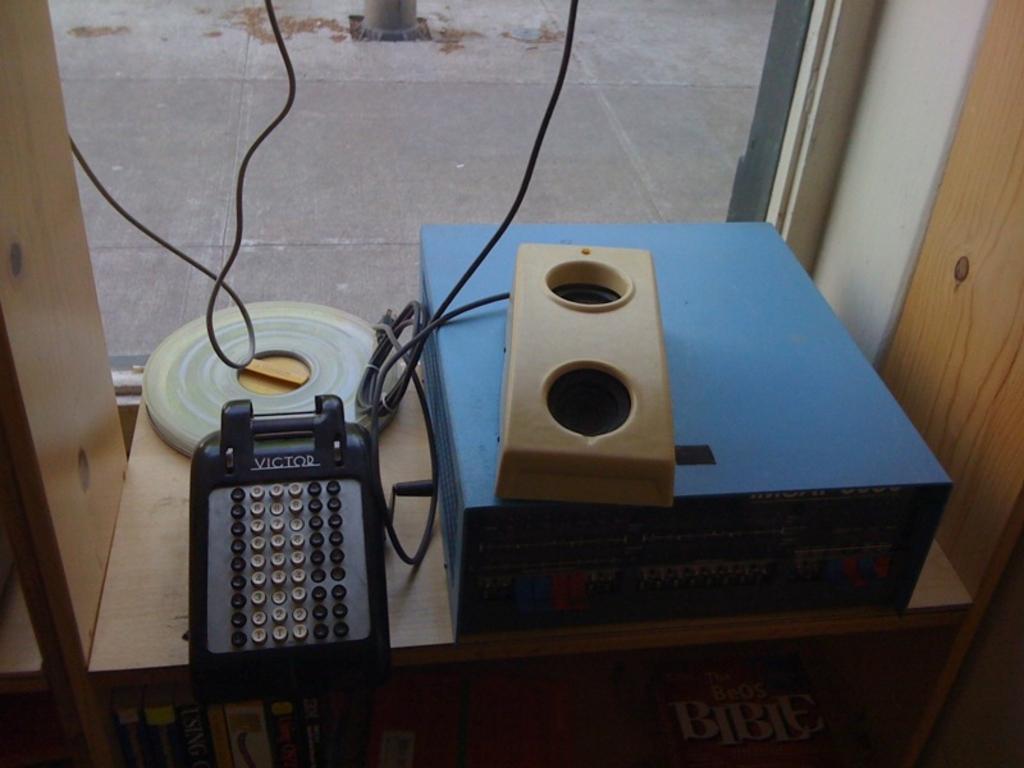Can you describe this image briefly? In this image there is a wooden table in the bottom of this image and there are some objects kept on it, and there are some wires attached to these objects as we can see in middle of this image. 